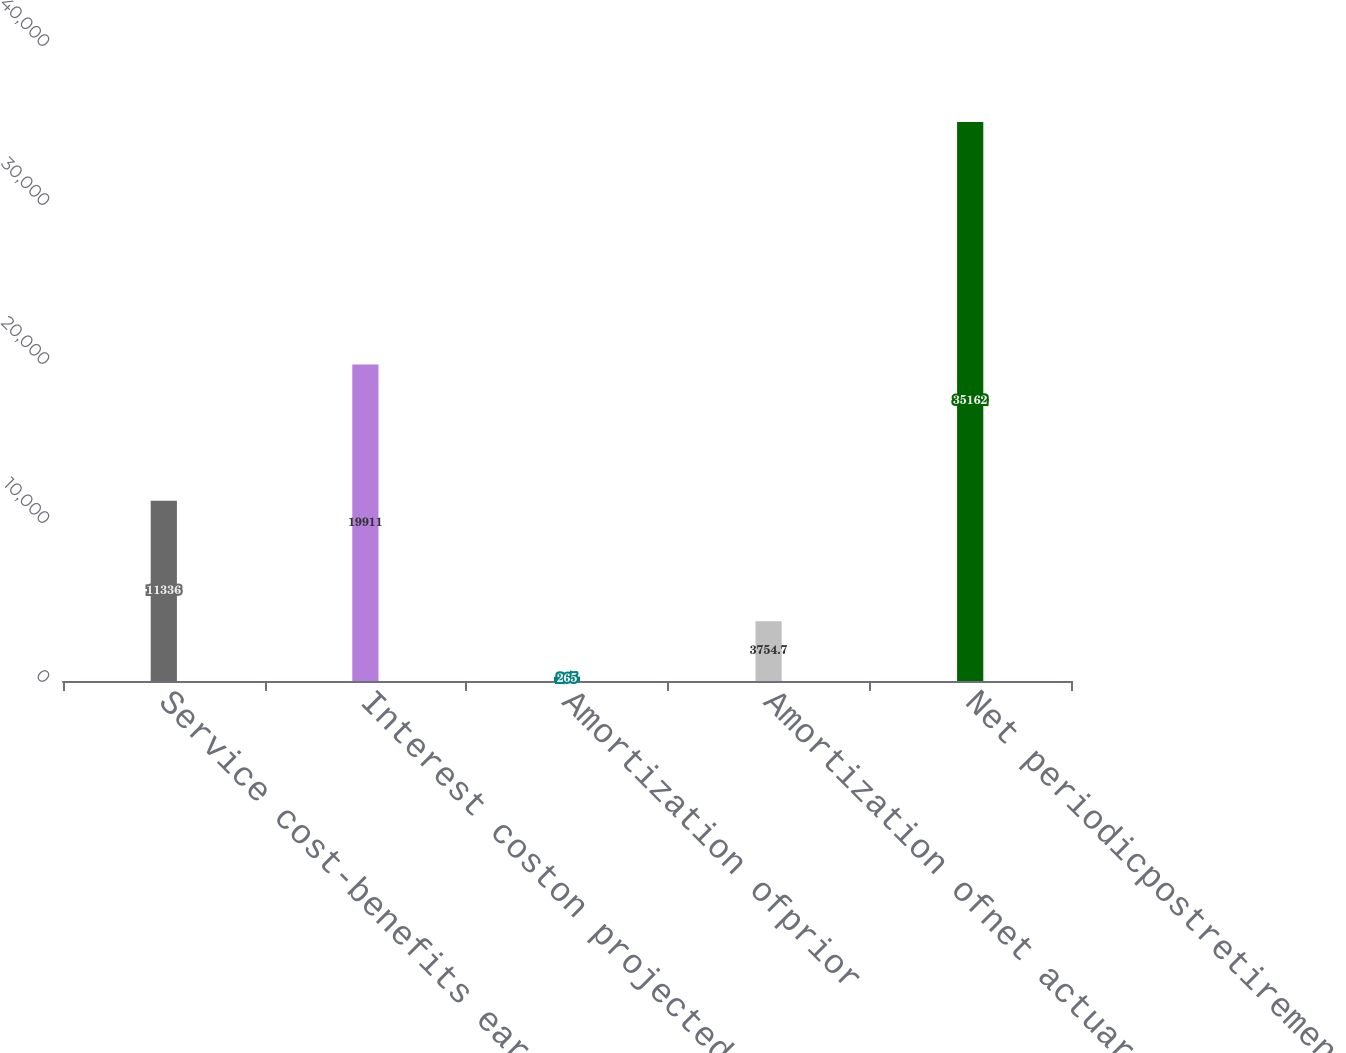<chart> <loc_0><loc_0><loc_500><loc_500><bar_chart><fcel>Service cost-benefits earned<fcel>Interest coston projected<fcel>Amortization ofprior<fcel>Amortization ofnet actuarial<fcel>Net periodicpostretirement<nl><fcel>11336<fcel>19911<fcel>265<fcel>3754.7<fcel>35162<nl></chart> 